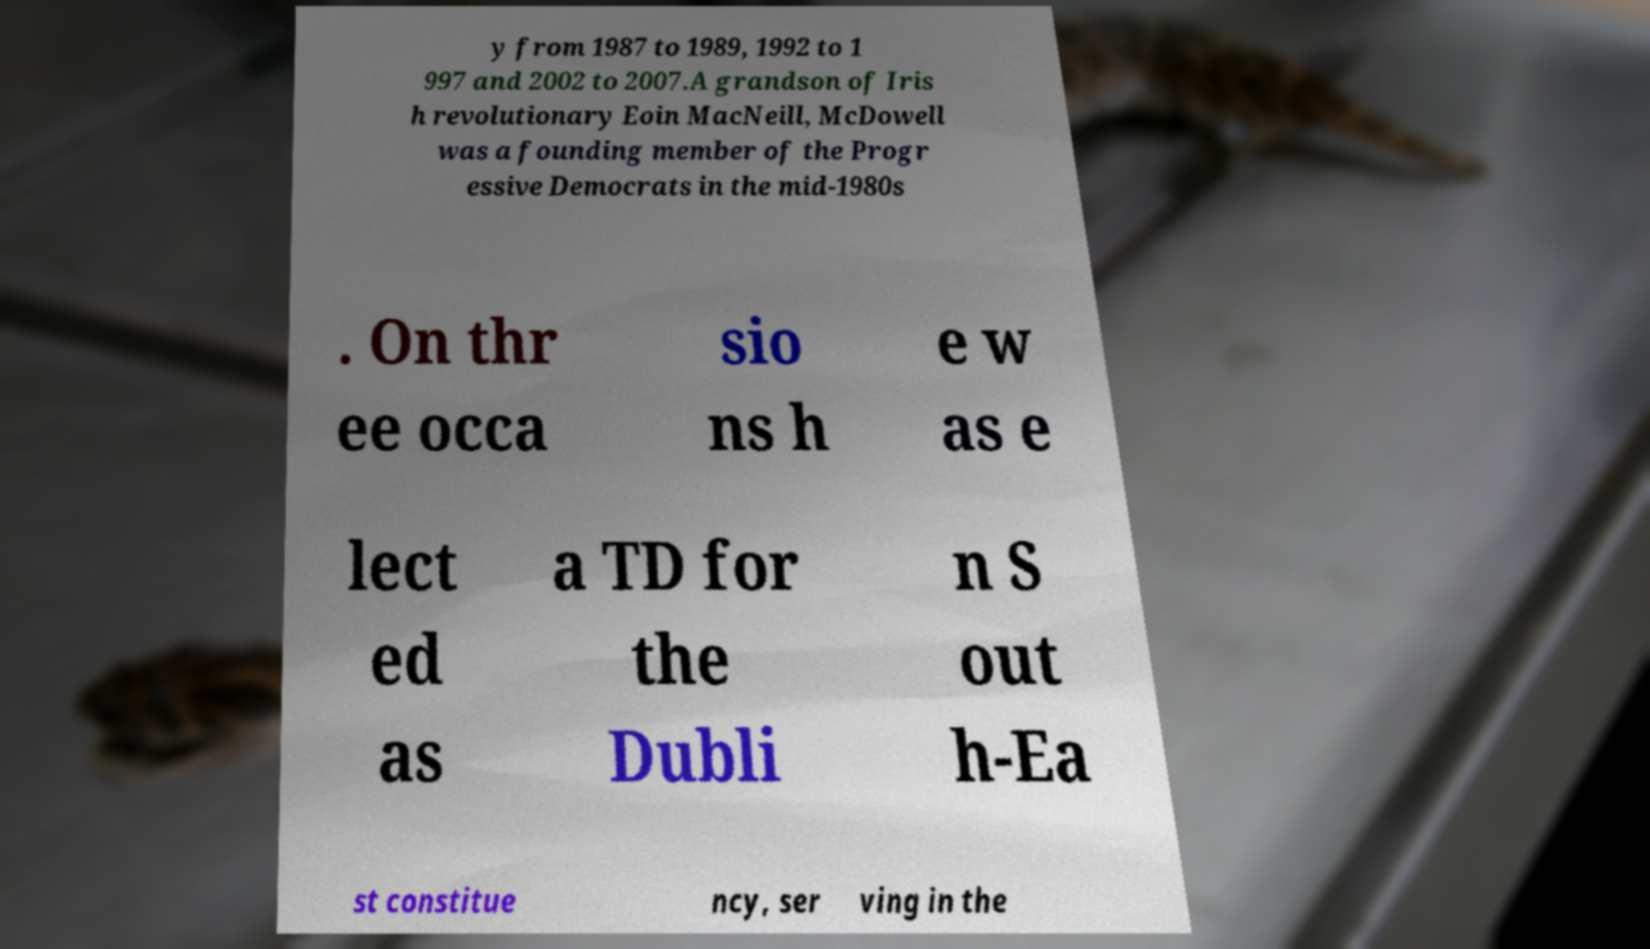For documentation purposes, I need the text within this image transcribed. Could you provide that? y from 1987 to 1989, 1992 to 1 997 and 2002 to 2007.A grandson of Iris h revolutionary Eoin MacNeill, McDowell was a founding member of the Progr essive Democrats in the mid-1980s . On thr ee occa sio ns h e w as e lect ed as a TD for the Dubli n S out h-Ea st constitue ncy, ser ving in the 